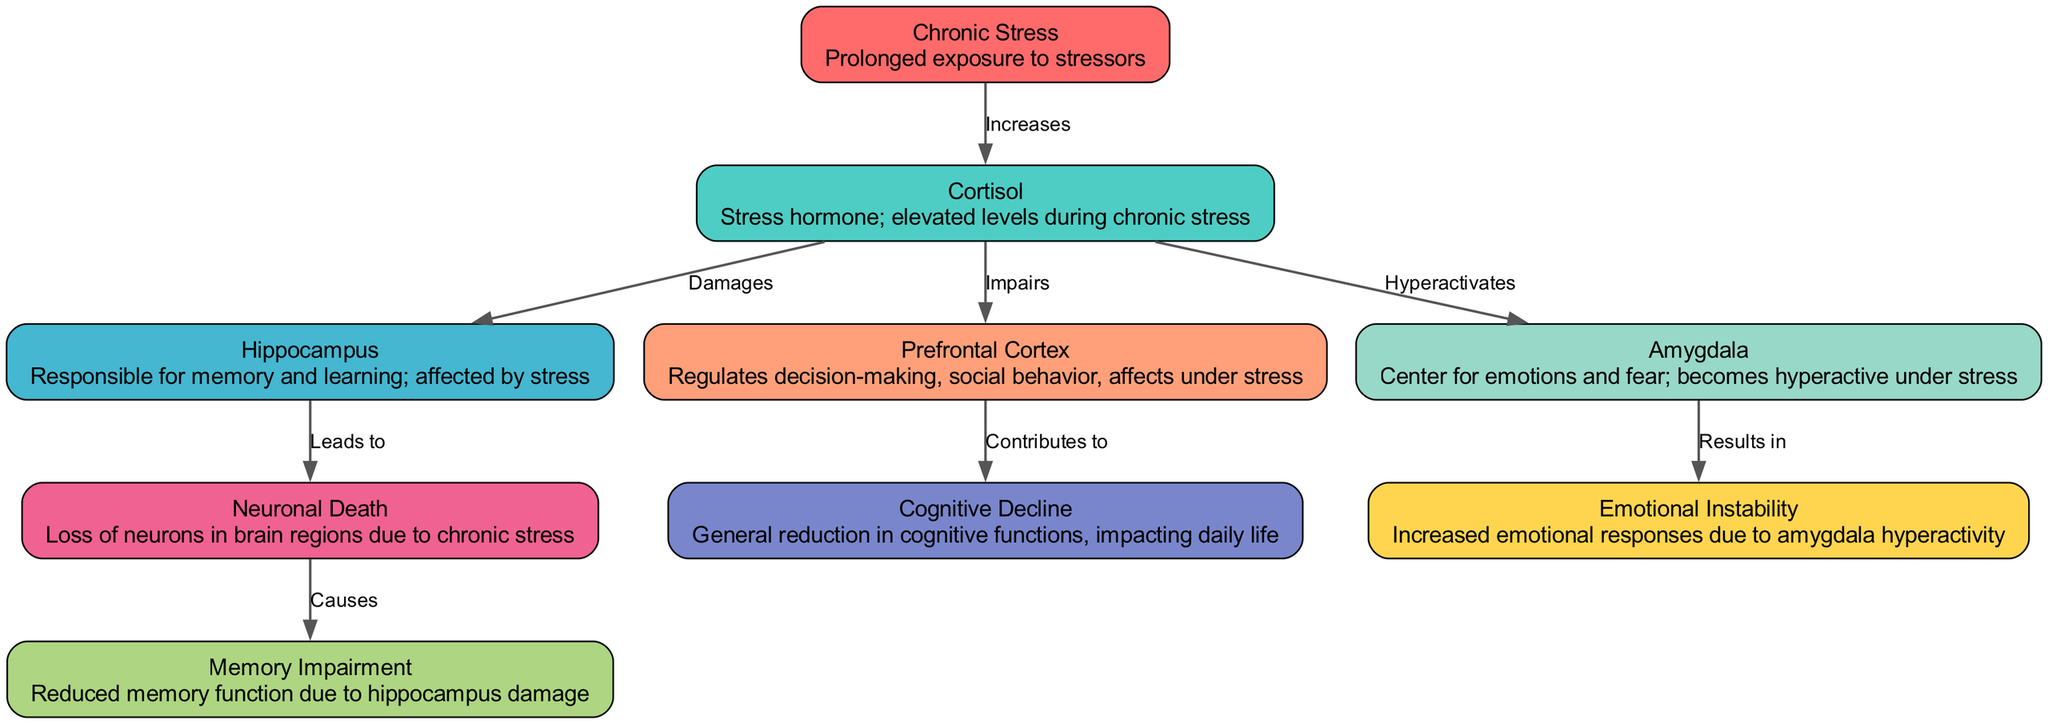What is the main factor leading to increased cortisol levels? The diagram indicates that the main factor is "Chronic Stress," which is linked directly to cortisol through an edge labeled "Increases."
Answer: Chronic Stress Which brain region is damaged by elevated cortisol? The edge from cortisol to hippocampus is labeled "Damages," indicating that the hippocampus is affected negatively by elevated cortisol levels.
Answer: Hippocampus What emotional condition results from the hyperactivity of the amygdala? The edge from amygdala to emotional instability is labeled "Results in," demonstrating that emotional instability is a direct consequence of amygdala hyperactivity.
Answer: Emotional Instability How many nodes are in the diagram? The data lists a total of nine nodes, indicating the various components related to chronic stress and its impact on the brain.
Answer: Nine What is the relationship between neuronal death and memory impairment? The labeled edge from neuronal death to memory impairment states "Causes," signifying that neuronal death leads to memory impairment.
Answer: Causes Which brain region does cortisol impair that contributes to cognitive decline? The diagram shows an edge from cortisol to prefrontal cortex labeled "Impairs," and another edge from prefrontal cortex to cognitive decline labeled "Contributes to," indicating the relationship across these three nodes.
Answer: Prefrontal Cortex What effect does chronic stress have on cortisol levels? There is a direct edge from chronic stress to cortisol with the label "Increases," indicating that chronic stress results in elevated levels of cortisol.
Answer: Increases Which two cognitive functions are mentioned in the diagram as being affected by chronic stress? The diagram indicates "Memory Impairment" (linked to neuronal death) and "Cognitive Decline" (linked to prefrontal cortex impairment) as outcomes affected by chronic stress.
Answer: Memory Impairment and Cognitive Decline What leads to neuronal death according to the diagram? The edge from the hippocampus to neuronal death is labeled "Leads to," indicating that damage to the hippocampus is the factor that leads to neuronal death.
Answer: Leads to 